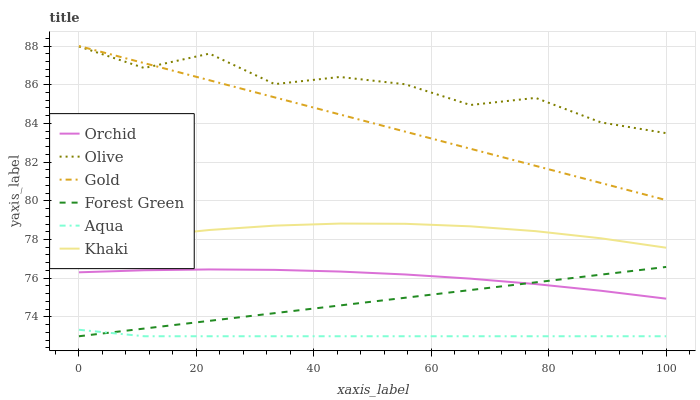Does Aqua have the minimum area under the curve?
Answer yes or no. Yes. Does Olive have the maximum area under the curve?
Answer yes or no. Yes. Does Gold have the minimum area under the curve?
Answer yes or no. No. Does Gold have the maximum area under the curve?
Answer yes or no. No. Is Forest Green the smoothest?
Answer yes or no. Yes. Is Olive the roughest?
Answer yes or no. Yes. Is Gold the smoothest?
Answer yes or no. No. Is Gold the roughest?
Answer yes or no. No. Does Aqua have the lowest value?
Answer yes or no. Yes. Does Gold have the lowest value?
Answer yes or no. No. Does Gold have the highest value?
Answer yes or no. Yes. Does Aqua have the highest value?
Answer yes or no. No. Is Aqua less than Khaki?
Answer yes or no. Yes. Is Gold greater than Khaki?
Answer yes or no. Yes. Does Aqua intersect Forest Green?
Answer yes or no. Yes. Is Aqua less than Forest Green?
Answer yes or no. No. Is Aqua greater than Forest Green?
Answer yes or no. No. Does Aqua intersect Khaki?
Answer yes or no. No. 